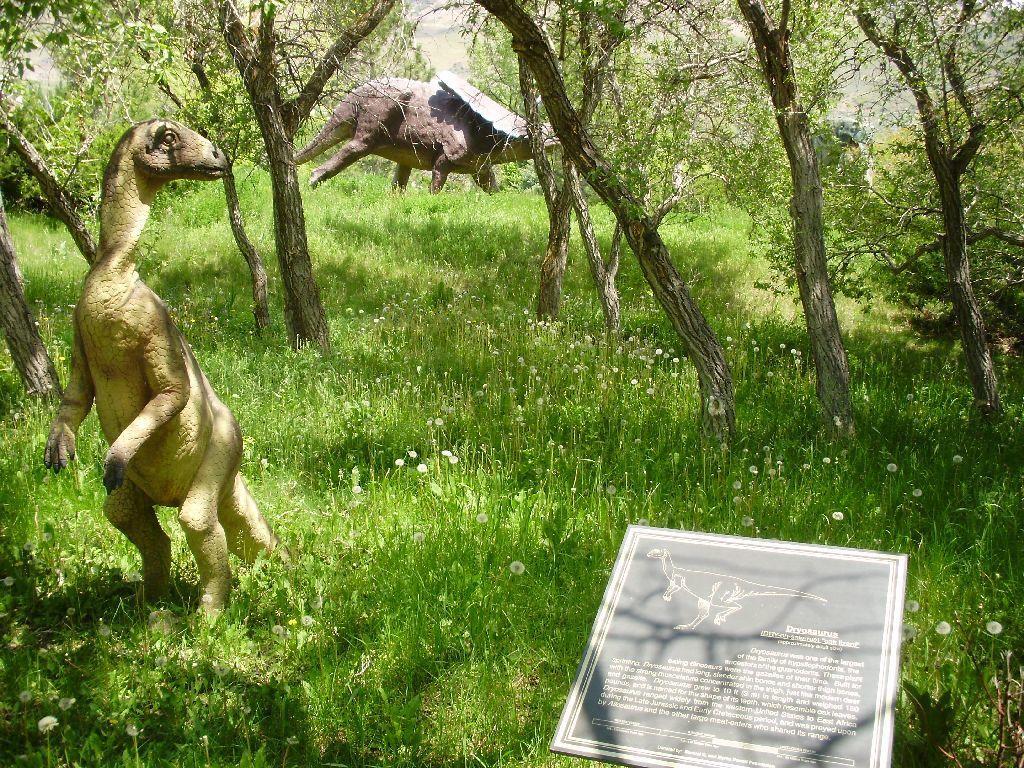Please provide a concise description of this image. As we can see in the image there is grass, trees, dinosaurs and a banner. 